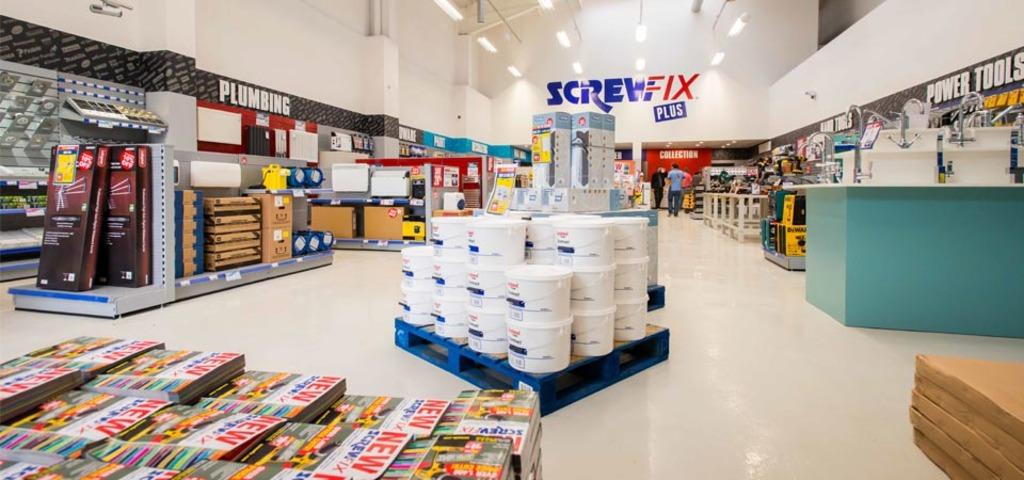<image>
Summarize the visual content of the image. the inside of a store that says the words 'screwfix plus' at the top 